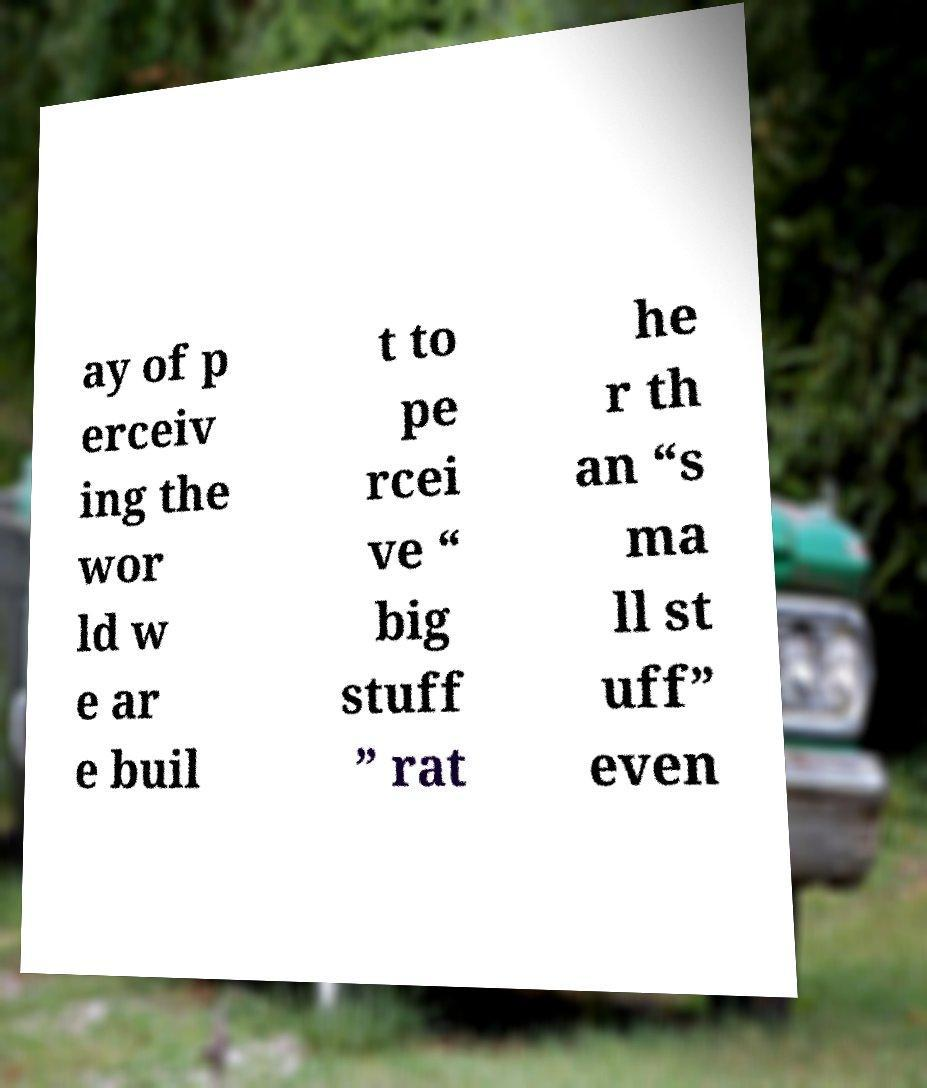Could you extract and type out the text from this image? ay of p erceiv ing the wor ld w e ar e buil t to pe rcei ve “ big stuff ” rat he r th an “s ma ll st uff” even 